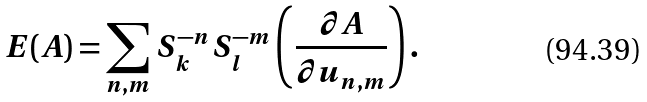Convert formula to latex. <formula><loc_0><loc_0><loc_500><loc_500>E ( A ) = \sum _ { n , m } S _ { k } ^ { - n } S _ { l } ^ { - m } \left ( \frac { \partial A } { \partial u _ { n , m } } \right ) .</formula> 